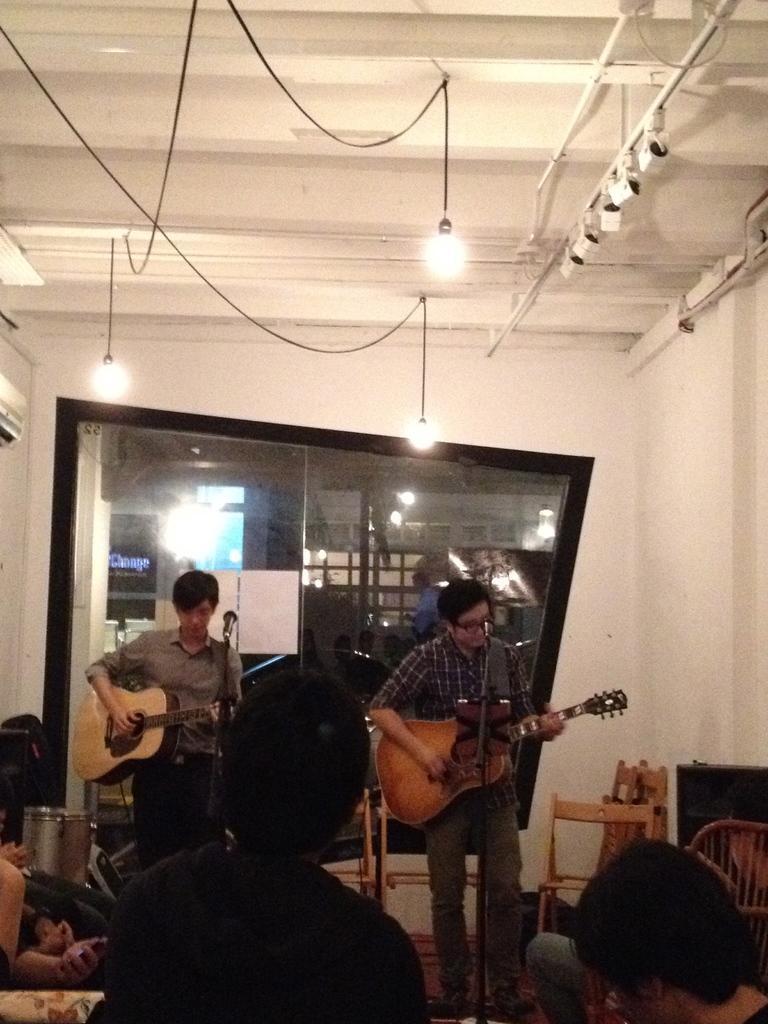Please provide a concise description of this image. In this image there are 2 persons standing and playing guitars near the microphone, and at the back ground there are group of people, couch, chairs ,speaker, lights, door, drums. 